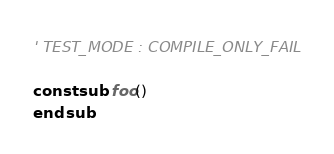Convert code to text. <code><loc_0><loc_0><loc_500><loc_500><_VisualBasic_>' TEST_MODE : COMPILE_ONLY_FAIL

const sub foo()
end sub
</code> 